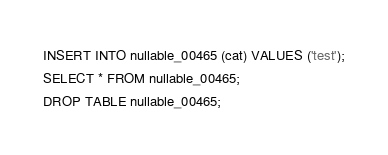<code> <loc_0><loc_0><loc_500><loc_500><_SQL_>INSERT INTO nullable_00465 (cat) VALUES ('test');
SELECT * FROM nullable_00465;
DROP TABLE nullable_00465;
</code> 